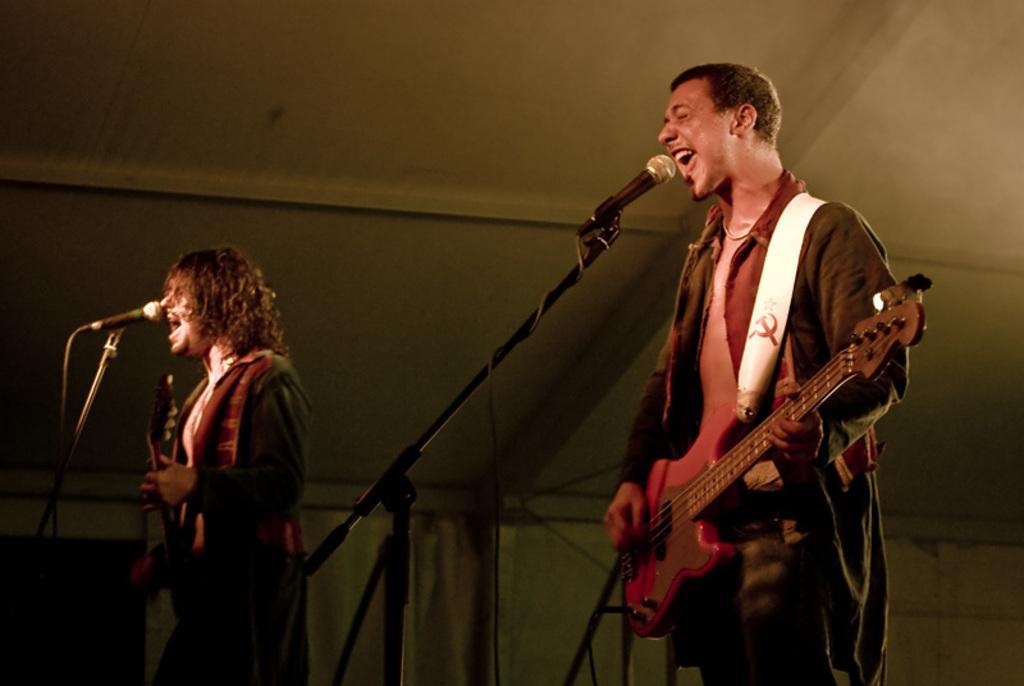How would you summarize this image in a sentence or two? In this image i can see 2 persons wearing jackets, standing and holding guitars in their hands. I can see microphones in front of them. In the background i can see the roof and the wall. 